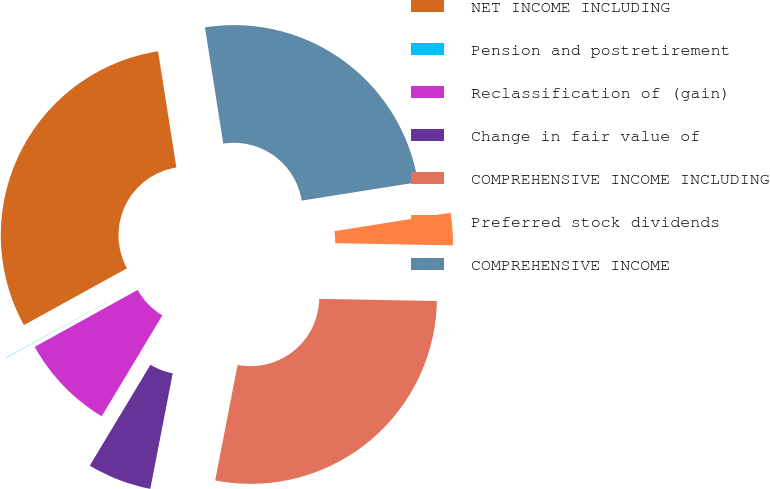Convert chart to OTSL. <chart><loc_0><loc_0><loc_500><loc_500><pie_chart><fcel>NET INCOME INCLUDING<fcel>Pension and postretirement<fcel>Reclassification of (gain)<fcel>Change in fair value of<fcel>COMPREHENSIVE INCOME INCLUDING<fcel>Preferred stock dividends<fcel>COMPREHENSIVE INCOME<nl><fcel>30.53%<fcel>0.03%<fcel>8.34%<fcel>5.57%<fcel>27.76%<fcel>2.8%<fcel>24.99%<nl></chart> 